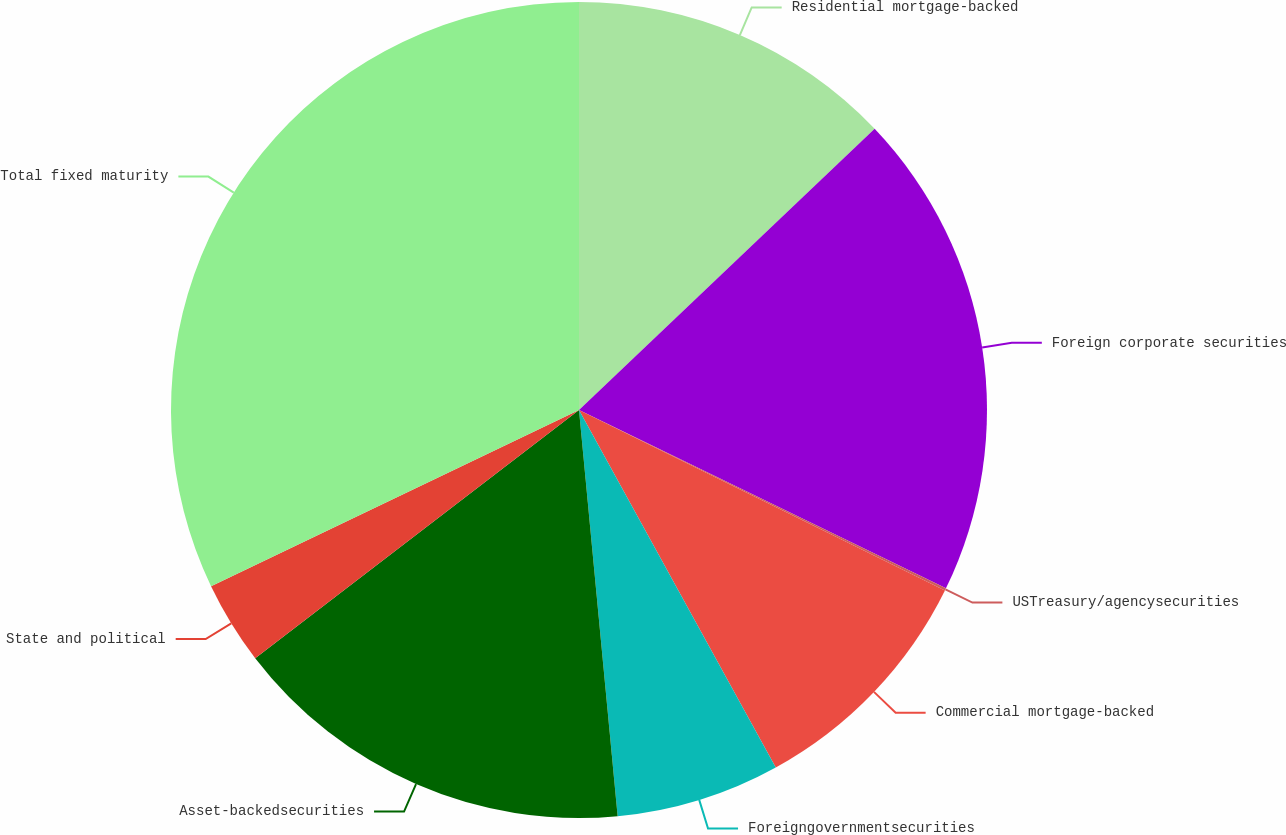Convert chart to OTSL. <chart><loc_0><loc_0><loc_500><loc_500><pie_chart><fcel>Residential mortgage-backed<fcel>Foreign corporate securities<fcel>USTreasury/agencysecurities<fcel>Commercial mortgage-backed<fcel>Foreigngovernmentsecurities<fcel>Asset-backedsecurities<fcel>State and political<fcel>Total fixed maturity<nl><fcel>12.9%<fcel>19.3%<fcel>0.09%<fcel>9.7%<fcel>6.5%<fcel>16.1%<fcel>3.3%<fcel>32.11%<nl></chart> 